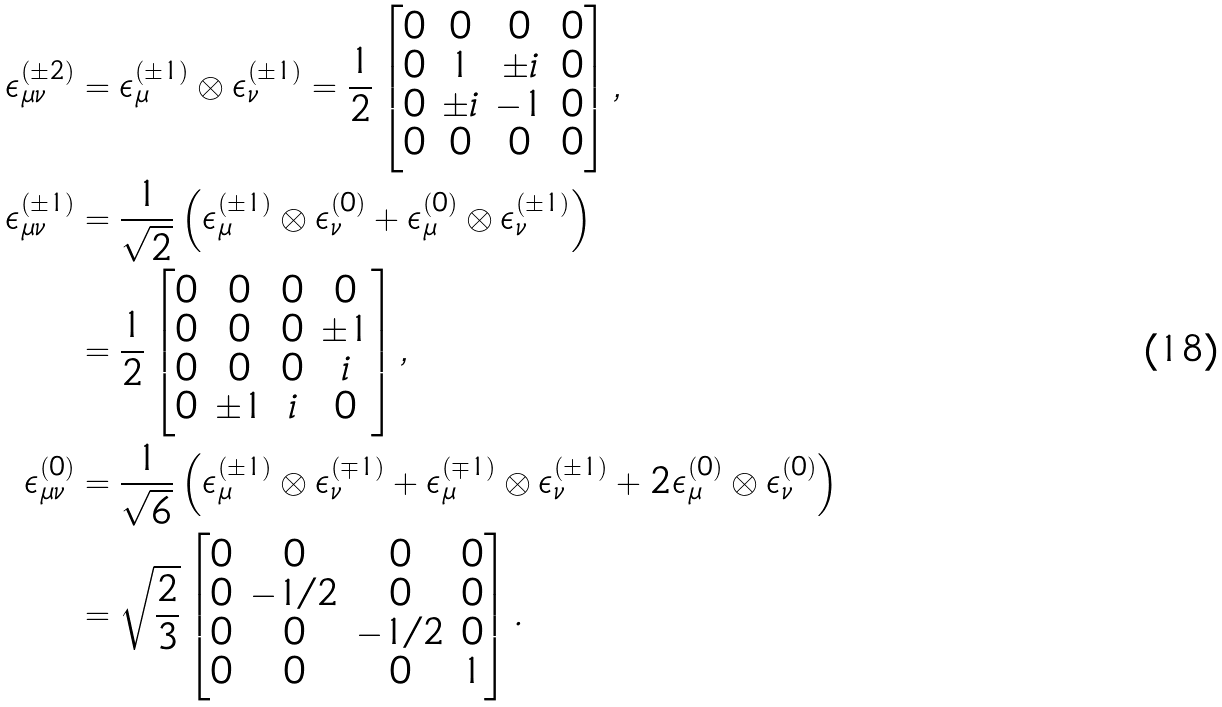<formula> <loc_0><loc_0><loc_500><loc_500>\epsilon ^ { ( \pm 2 ) } _ { \mu \nu } & = \epsilon ^ { ( \pm 1 ) } _ { \mu } \otimes \epsilon ^ { ( \pm 1 ) } _ { \nu } = \frac { 1 } { 2 } \begin{bmatrix} 0 & 0 & 0 & 0 \\ 0 & 1 & \pm i & 0 \\ 0 & \pm i & - 1 & 0 \\ 0 & 0 & 0 & 0 \end{bmatrix} , \\ \epsilon ^ { ( \pm 1 ) } _ { \mu \nu } & = \frac { 1 } { \sqrt { 2 } } \left ( \epsilon ^ { ( \pm 1 ) } _ { \mu } \otimes \epsilon ^ { ( 0 ) } _ { \nu } + \epsilon ^ { ( 0 ) } _ { \mu } \otimes \epsilon ^ { ( \pm 1 ) } _ { \nu } \right ) \\ & = \frac { 1 } { 2 } \begin{bmatrix} 0 & 0 & 0 & 0 \\ 0 & 0 & 0 & \pm 1 \\ 0 & 0 & 0 & i \\ 0 & \pm 1 & i & 0 \end{bmatrix} , \\ \epsilon ^ { ( 0 ) } _ { \mu \nu } & = \frac { 1 } { \sqrt { 6 } } \left ( \epsilon ^ { ( \pm 1 ) } _ { \mu } \otimes \epsilon ^ { ( \mp 1 ) } _ { \nu } + \epsilon ^ { ( \mp 1 ) } _ { \mu } \otimes \epsilon ^ { ( \pm 1 ) } _ { \nu } + 2 \epsilon ^ { ( 0 ) } _ { \mu } \otimes \epsilon ^ { ( 0 ) } _ { \nu } \right ) \\ & = \sqrt { \frac { 2 } { 3 } } \begin{bmatrix} 0 & 0 & 0 & 0 \\ 0 & - 1 / 2 & 0 & 0 \\ 0 & 0 & - 1 / 2 & 0 \\ 0 & 0 & 0 & 1 \end{bmatrix} .</formula> 